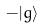Convert formula to latex. <formula><loc_0><loc_0><loc_500><loc_500>- | g \rangle</formula> 